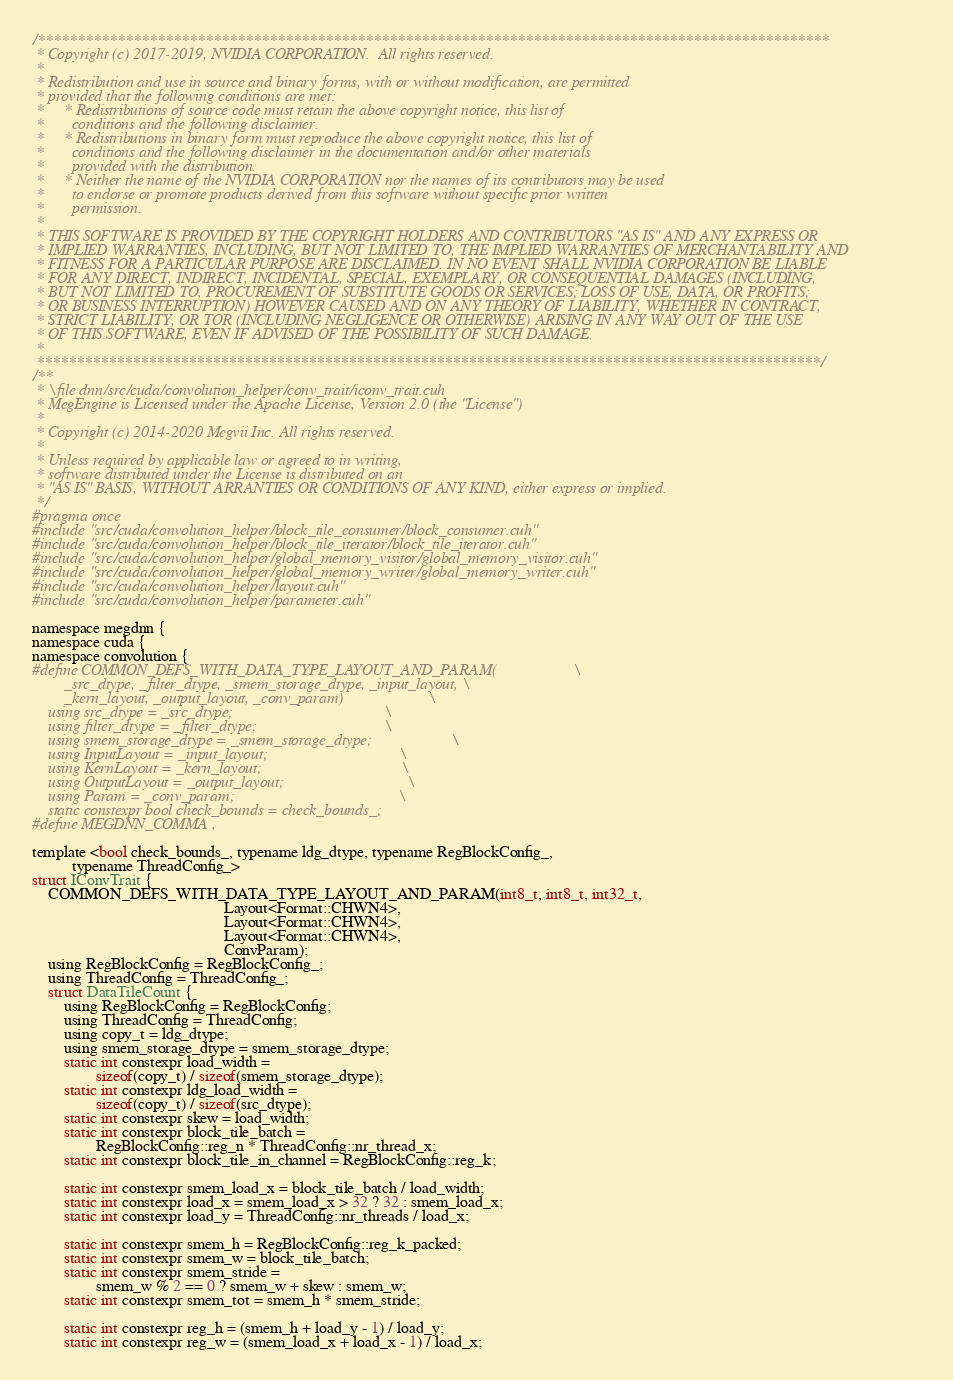Convert code to text. <code><loc_0><loc_0><loc_500><loc_500><_Cuda_>/***************************************************************************************************
 * Copyright (c) 2017-2019, NVIDIA CORPORATION.  All rights reserved.
 *
 * Redistribution and use in source and binary forms, with or without modification, are permitted
 * provided that the following conditions are met:
 *     * Redistributions of source code must retain the above copyright notice, this list of
 *       conditions and the following disclaimer.
 *     * Redistributions in binary form must reproduce the above copyright notice, this list of
 *       conditions and the following disclaimer in the documentation and/or other materials
 *       provided with the distribution.
 *     * Neither the name of the NVIDIA CORPORATION nor the names of its contributors may be used
 *       to endorse or promote products derived from this software without specific prior written
 *       permission.
 *
 * THIS SOFTWARE IS PROVIDED BY THE COPYRIGHT HOLDERS AND CONTRIBUTORS "AS IS" AND ANY EXPRESS OR
 * IMPLIED WARRANTIES, INCLUDING, BUT NOT LIMITED TO, THE IMPLIED WARRANTIES OF MERCHANTABILITY AND
 * FITNESS FOR A PARTICULAR PURPOSE ARE DISCLAIMED. IN NO EVENT SHALL NVIDIA CORPORATION BE LIABLE
 * FOR ANY DIRECT, INDIRECT, INCIDENTAL, SPECIAL, EXEMPLARY, OR CONSEQUENTIAL DAMAGES (INCLUDING,
 * BUT NOT LIMITED TO, PROCUREMENT OF SUBSTITUTE GOODS OR SERVICES; LOSS OF USE, DATA, OR PROFITS;
 * OR BUSINESS INTERRUPTION) HOWEVER CAUSED AND ON ANY THEORY OF LIABILITY, WHETHER IN CONTRACT,
 * STRICT LIABILITY, OR TOR (INCLUDING NEGLIGENCE OR OTHERWISE) ARISING IN ANY WAY OUT OF THE USE
 * OF THIS SOFTWARE, EVEN IF ADVISED OF THE POSSIBILITY OF SUCH DAMAGE.
 *
 **************************************************************************************************/
/**
 * \file dnn/src/cuda/convolution_helper/conv_trait/iconv_trait.cuh
 * MegEngine is Licensed under the Apache License, Version 2.0 (the "License")
 *
 * Copyright (c) 2014-2020 Megvii Inc. All rights reserved.
 *
 * Unless required by applicable law or agreed to in writing,
 * software distributed under the License is distributed on an
 * "AS IS" BASIS, WITHOUT ARRANTIES OR CONDITIONS OF ANY KIND, either express or implied.
 */
#pragma once
#include "src/cuda/convolution_helper/block_tile_consumer/block_consumer.cuh"
#include "src/cuda/convolution_helper/block_tile_iterator/block_tile_iterator.cuh"
#include "src/cuda/convolution_helper/global_memory_visitor/global_memory_visitor.cuh"
#include "src/cuda/convolution_helper/global_memory_writer/global_memory_writer.cuh"
#include "src/cuda/convolution_helper/layout.cuh"
#include "src/cuda/convolution_helper/parameter.cuh"

namespace megdnn {
namespace cuda {
namespace convolution {
#define COMMON_DEFS_WITH_DATA_TYPE_LAYOUT_AND_PARAM(                   \
        _src_dtype, _filter_dtype, _smem_storage_dtype, _input_layout, \
        _kern_layout, _output_layout, _conv_param)                     \
    using src_dtype = _src_dtype;                                      \
    using filter_dtype = _filter_dtype;                                \
    using smem_storage_dtype = _smem_storage_dtype;                    \
    using InputLayout = _input_layout;                                 \
    using KernLayout = _kern_layout;                                   \
    using OutputLayout = _output_layout;                               \
    using Param = _conv_param;                                         \
    static constexpr bool check_bounds = check_bounds_;
#define MEGDNN_COMMA ,

template <bool check_bounds_, typename ldg_dtype, typename RegBlockConfig_,
          typename ThreadConfig_>
struct IConvTrait {
    COMMON_DEFS_WITH_DATA_TYPE_LAYOUT_AND_PARAM(int8_t, int8_t, int32_t,
                                                Layout<Format::CHWN4>,
                                                Layout<Format::CHWN4>,
                                                Layout<Format::CHWN4>,
                                                ConvParam);
    using RegBlockConfig = RegBlockConfig_;
    using ThreadConfig = ThreadConfig_;
    struct DataTileCount {
        using RegBlockConfig = RegBlockConfig;
        using ThreadConfig = ThreadConfig;
        using copy_t = ldg_dtype;
        using smem_storage_dtype = smem_storage_dtype;
        static int constexpr load_width =
                sizeof(copy_t) / sizeof(smem_storage_dtype);
        static int constexpr ldg_load_width =
                sizeof(copy_t) / sizeof(src_dtype);
        static int constexpr skew = load_width;
        static int constexpr block_tile_batch =
                RegBlockConfig::reg_n * ThreadConfig::nr_thread_x;
        static int constexpr block_tile_in_channel = RegBlockConfig::reg_k;

        static int constexpr smem_load_x = block_tile_batch / load_width;
        static int constexpr load_x = smem_load_x > 32 ? 32 : smem_load_x;
        static int constexpr load_y = ThreadConfig::nr_threads / load_x;

        static int constexpr smem_h = RegBlockConfig::reg_k_packed;
        static int constexpr smem_w = block_tile_batch;
        static int constexpr smem_stride =
                smem_w % 2 == 0 ? smem_w + skew : smem_w;
        static int constexpr smem_tot = smem_h * smem_stride;

        static int constexpr reg_h = (smem_h + load_y - 1) / load_y;
        static int constexpr reg_w = (smem_load_x + load_x - 1) / load_x;
</code> 